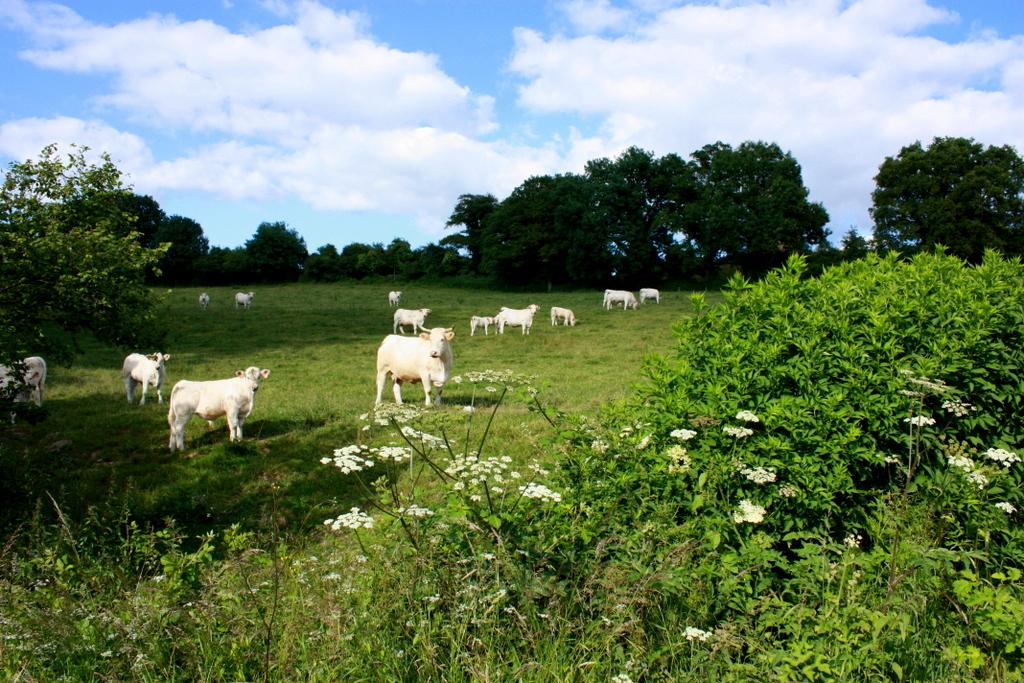What type of living organisms can be seen in the image? There are animals in the image. Where are the animals located? The animals are on the grass. What other types of plants are visible in the image besides grass? There are plants with flowers in the image. How are the plants with flowers positioned in relation to the animals? The plants with flowers are in front of the animals. What can be seen in the background of the image? There are trees and the sky visible in the background of the image. What type of metal object is being used by the animals in the image? There is no metal object present in the image; the animals are on the grass and surrounded by plants. What time is indicated by the clock in the image? There is no clock present in the image; it features animals, plants, and trees. 